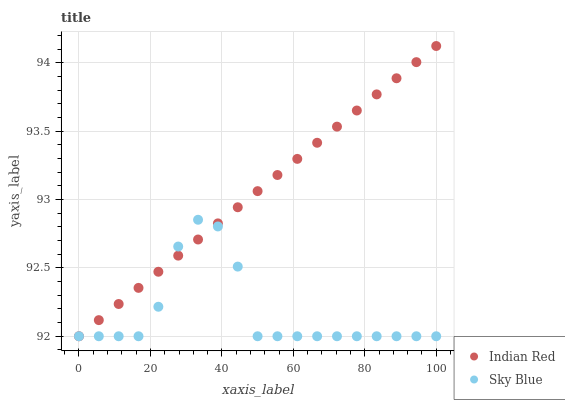Does Sky Blue have the minimum area under the curve?
Answer yes or no. Yes. Does Indian Red have the maximum area under the curve?
Answer yes or no. Yes. Does Indian Red have the minimum area under the curve?
Answer yes or no. No. Is Indian Red the smoothest?
Answer yes or no. Yes. Is Sky Blue the roughest?
Answer yes or no. Yes. Is Indian Red the roughest?
Answer yes or no. No. Does Sky Blue have the lowest value?
Answer yes or no. Yes. Does Indian Red have the highest value?
Answer yes or no. Yes. Does Sky Blue intersect Indian Red?
Answer yes or no. Yes. Is Sky Blue less than Indian Red?
Answer yes or no. No. Is Sky Blue greater than Indian Red?
Answer yes or no. No. 